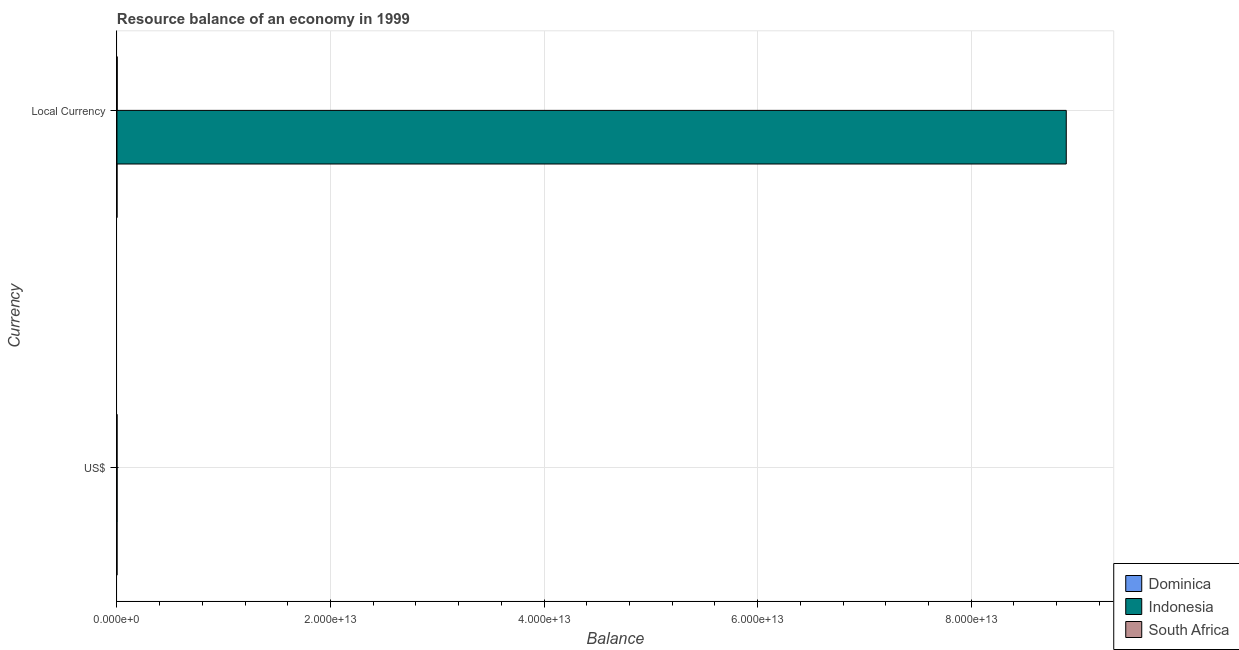How many groups of bars are there?
Give a very brief answer. 2. How many bars are there on the 1st tick from the top?
Make the answer very short. 2. What is the label of the 1st group of bars from the top?
Your answer should be very brief. Local Currency. What is the resource balance in us$ in Indonesia?
Ensure brevity in your answer.  1.13e+1. Across all countries, what is the maximum resource balance in us$?
Your answer should be very brief. 1.13e+1. Across all countries, what is the minimum resource balance in us$?
Ensure brevity in your answer.  0. In which country was the resource balance in us$ maximum?
Your answer should be very brief. Indonesia. What is the total resource balance in constant us$ in the graph?
Your answer should be very brief. 8.89e+13. What is the difference between the resource balance in constant us$ in South Africa and that in Indonesia?
Keep it short and to the point. -8.89e+13. What is the difference between the resource balance in constant us$ in Dominica and the resource balance in us$ in South Africa?
Provide a short and direct response. -3.45e+09. What is the average resource balance in us$ per country?
Make the answer very short. 4.92e+09. What is the difference between the resource balance in constant us$ and resource balance in us$ in South Africa?
Provide a short and direct response. 1.77e+1. What is the ratio of the resource balance in us$ in Indonesia to that in South Africa?
Keep it short and to the point. 3.28. How many bars are there?
Offer a very short reply. 4. Are all the bars in the graph horizontal?
Give a very brief answer. Yes. What is the difference between two consecutive major ticks on the X-axis?
Your response must be concise. 2.00e+13. Are the values on the major ticks of X-axis written in scientific E-notation?
Offer a terse response. Yes. Where does the legend appear in the graph?
Keep it short and to the point. Bottom right. How are the legend labels stacked?
Offer a very short reply. Vertical. What is the title of the graph?
Ensure brevity in your answer.  Resource balance of an economy in 1999. What is the label or title of the X-axis?
Your answer should be compact. Balance. What is the label or title of the Y-axis?
Give a very brief answer. Currency. What is the Balance of Indonesia in US$?
Your answer should be very brief. 1.13e+1. What is the Balance of South Africa in US$?
Make the answer very short. 3.45e+09. What is the Balance in Indonesia in Local Currency?
Offer a very short reply. 8.89e+13. What is the Balance in South Africa in Local Currency?
Provide a short and direct response. 2.11e+1. Across all Currency, what is the maximum Balance in Indonesia?
Give a very brief answer. 8.89e+13. Across all Currency, what is the maximum Balance in South Africa?
Ensure brevity in your answer.  2.11e+1. Across all Currency, what is the minimum Balance in Indonesia?
Your response must be concise. 1.13e+1. Across all Currency, what is the minimum Balance of South Africa?
Give a very brief answer. 3.45e+09. What is the total Balance of Dominica in the graph?
Your answer should be very brief. 0. What is the total Balance of Indonesia in the graph?
Ensure brevity in your answer.  8.89e+13. What is the total Balance of South Africa in the graph?
Your response must be concise. 2.46e+1. What is the difference between the Balance of Indonesia in US$ and that in Local Currency?
Offer a terse response. -8.89e+13. What is the difference between the Balance of South Africa in US$ and that in Local Currency?
Your response must be concise. -1.77e+1. What is the difference between the Balance in Indonesia in US$ and the Balance in South Africa in Local Currency?
Ensure brevity in your answer.  -9.79e+09. What is the average Balance in Indonesia per Currency?
Keep it short and to the point. 4.45e+13. What is the average Balance of South Africa per Currency?
Your answer should be compact. 1.23e+1. What is the difference between the Balance of Indonesia and Balance of South Africa in US$?
Your answer should be compact. 7.86e+09. What is the difference between the Balance in Indonesia and Balance in South Africa in Local Currency?
Provide a short and direct response. 8.89e+13. What is the ratio of the Balance in Indonesia in US$ to that in Local Currency?
Give a very brief answer. 0. What is the ratio of the Balance in South Africa in US$ to that in Local Currency?
Provide a succinct answer. 0.16. What is the difference between the highest and the second highest Balance in Indonesia?
Ensure brevity in your answer.  8.89e+13. What is the difference between the highest and the second highest Balance of South Africa?
Your response must be concise. 1.77e+1. What is the difference between the highest and the lowest Balance of Indonesia?
Offer a very short reply. 8.89e+13. What is the difference between the highest and the lowest Balance of South Africa?
Your answer should be compact. 1.77e+1. 